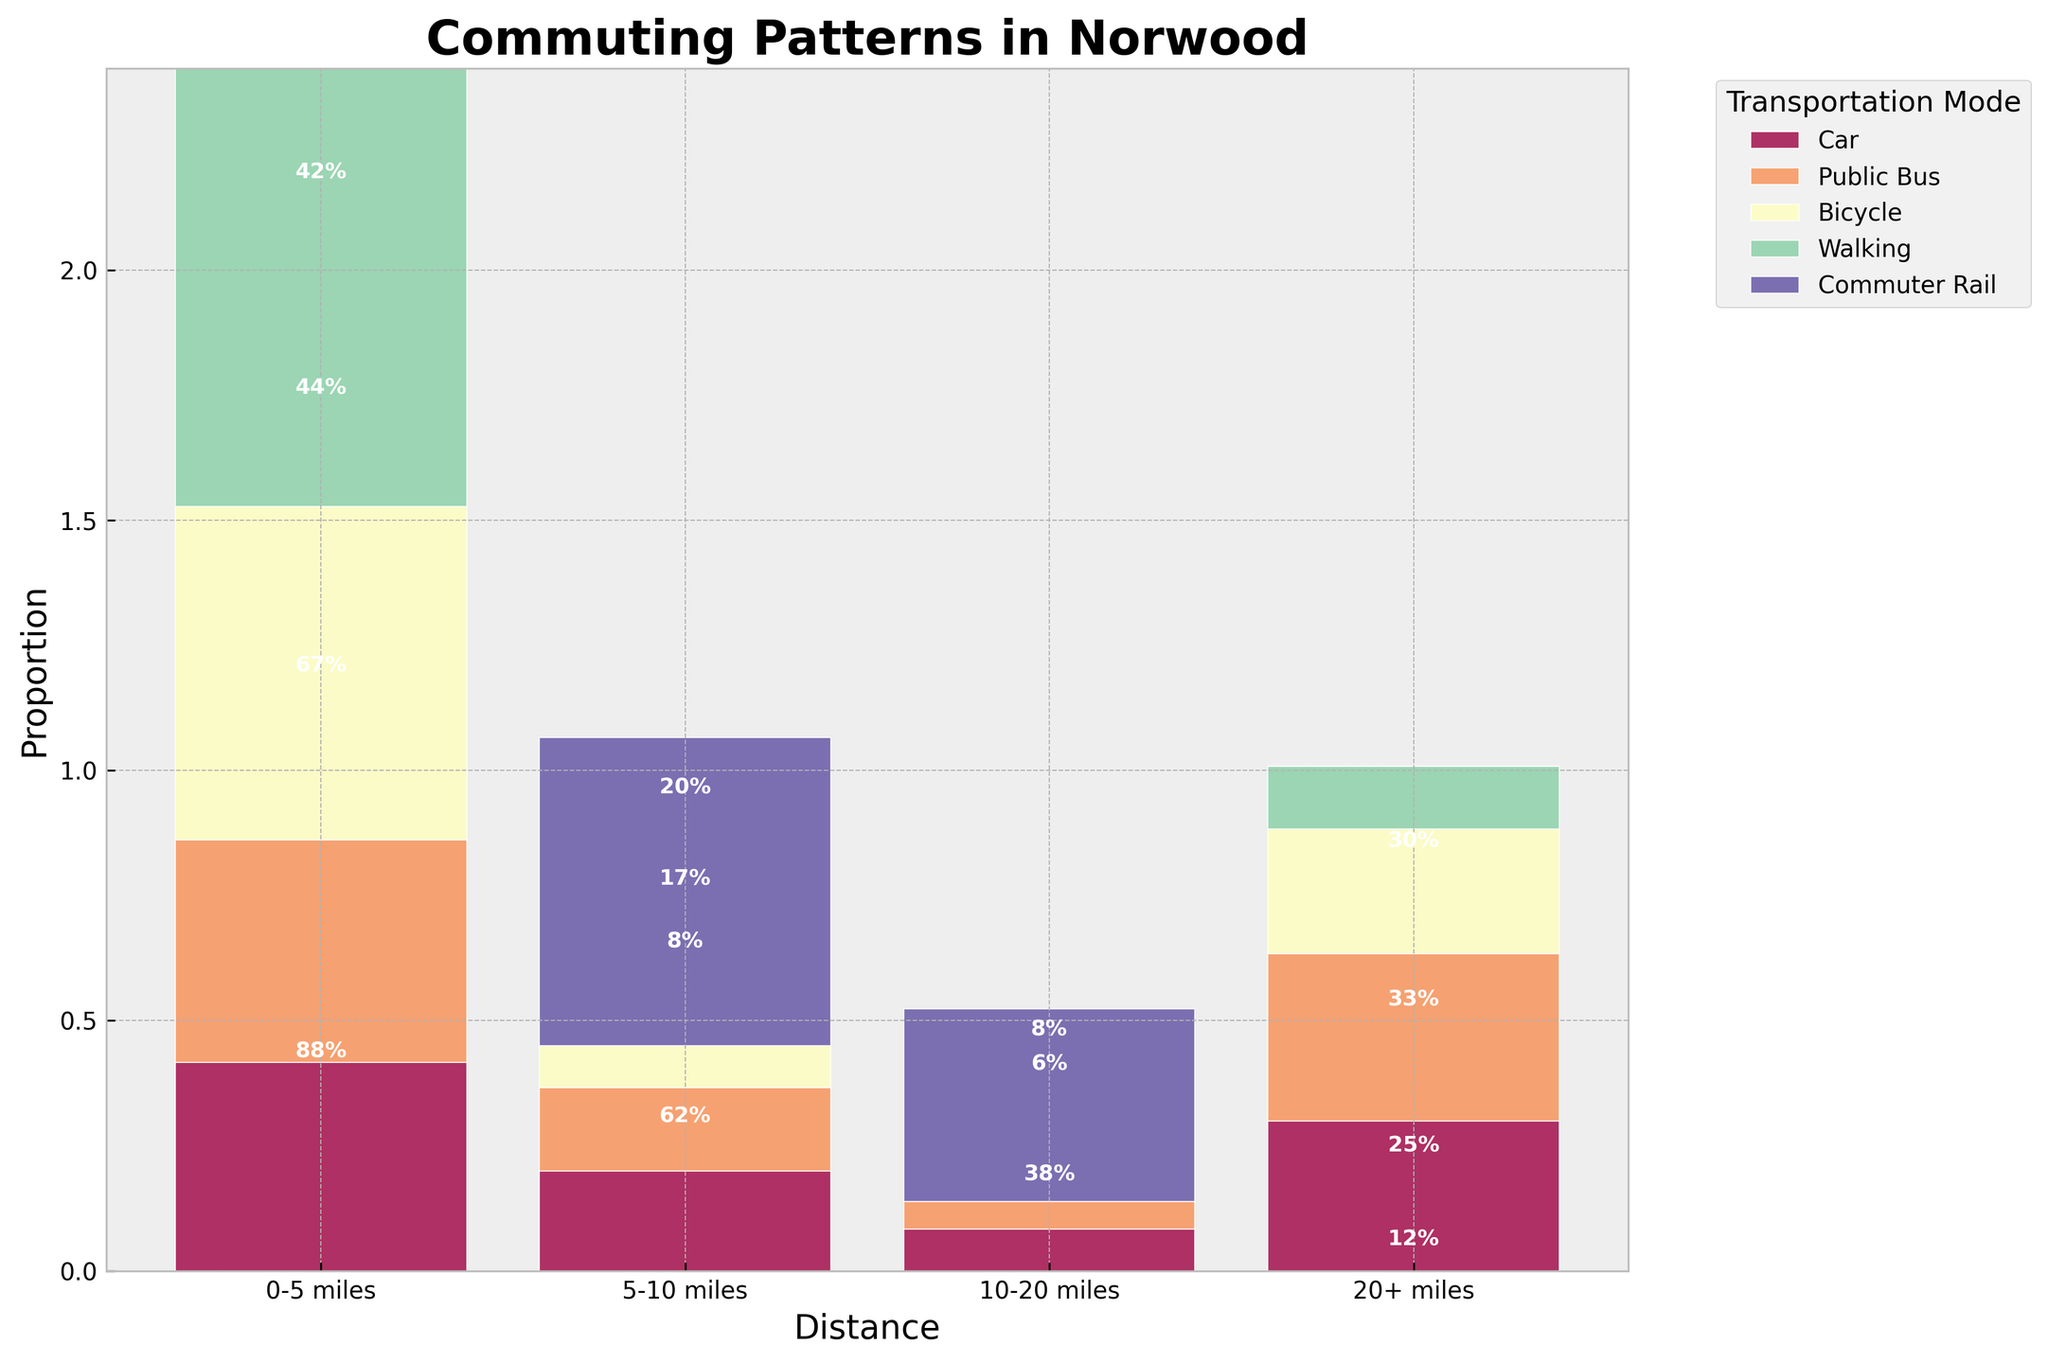What is the title of the plot? The title is usually positioned at the top of the plot and it reads "Commuting Patterns in Norwood".
Answer: Commuting Patterns in Norwood Which transportation mode has the maximum proportion for 0-5 miles? Look at the bar segment for 0-5 miles. The Car section is clearly the largest.
Answer: Car How many transportation modes are represented in the plot? The legend on the right-hand side of the plot shows all represented modes. Count these unique modes.
Answer: 5 For the 5-10 miles range, which transportation mode has the least proportion? Check the 5-10 miles segment. The Walking section is the smallest.
Answer: Walking What proportion of people use Public Bus for 0-5 miles? Look at the Public Bus section in the 0-5 miles bar and read the proportion label inside the segment or judge its size if a label is missing.
Answer: 0.16 or 16% Which distance range has the smallest proportion of Bicycle users? Evaluate the sections representing Bicycle use over each distance. The 10-20 miles range is the smallest.
Answer: 10-20 miles Is there any transportation mode for the 10-20 miles range where the proportion exceeds 35%? Check the height of each segment within the 10-20 miles bar. None appear to exceed this threshold.
Answer: No How does the proportion of Commuter Rail use for 20+ miles compare to Bicycle use for 0-5 miles? Look at the 20+ miles section for Commuter Rail and the 0-5 miles section for Bicycles. The Commuter Rail segment is proportionally larger.
Answer: Commuter Rail is higher Which has a higher proportion for 5-10 miles: Cars or Public Buses? Compare the bar heights for Cars and Public Buses in the 5-10 miles column. Cars are definitely higher.
Answer: Cars What is the sum of proportions for Car across all distances? Sum the proportions of Car for each distance (0-5, 5-10, 10-20, and 20+ miles) using the bar segment heights or proportion labels.
Answer: 1 or 100% 